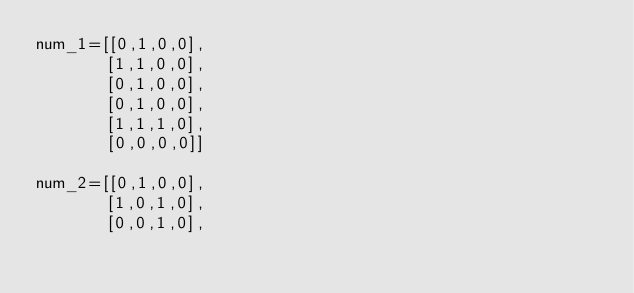Convert code to text. <code><loc_0><loc_0><loc_500><loc_500><_Python_>num_1=[[0,1,0,0],
       [1,1,0,0],
       [0,1,0,0],
       [0,1,0,0],
       [1,1,1,0],
       [0,0,0,0]]

num_2=[[0,1,0,0],
       [1,0,1,0],
       [0,0,1,0],</code> 